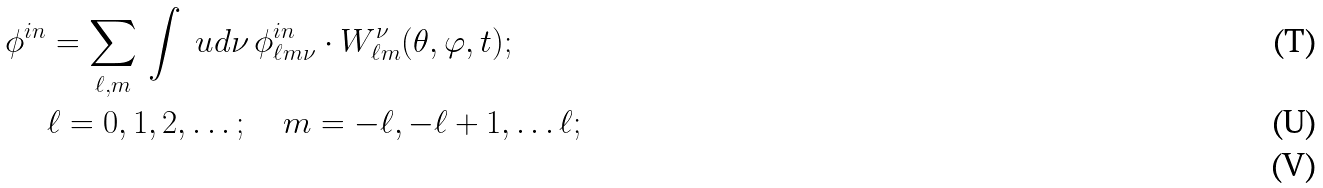<formula> <loc_0><loc_0><loc_500><loc_500>\phi ^ { i n } & = \sum _ { \ell , m } \, \int \ u d \nu \, \phi _ { \ell m \nu } ^ { i n } \cdot W _ { \ell m } ^ { \nu } ( \theta , \varphi , t ) ; \\ & \ell = 0 , 1 , 2 , \dots ; \quad m = - \ell , - \ell + 1 , \dots \ell ; \\</formula> 